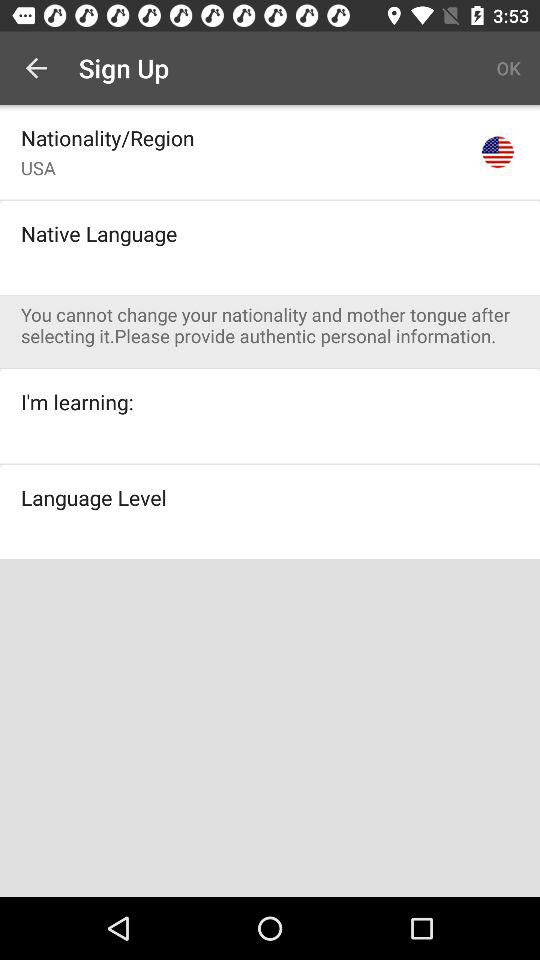What is the selected nationality? The selected nationality is the United States of America. 